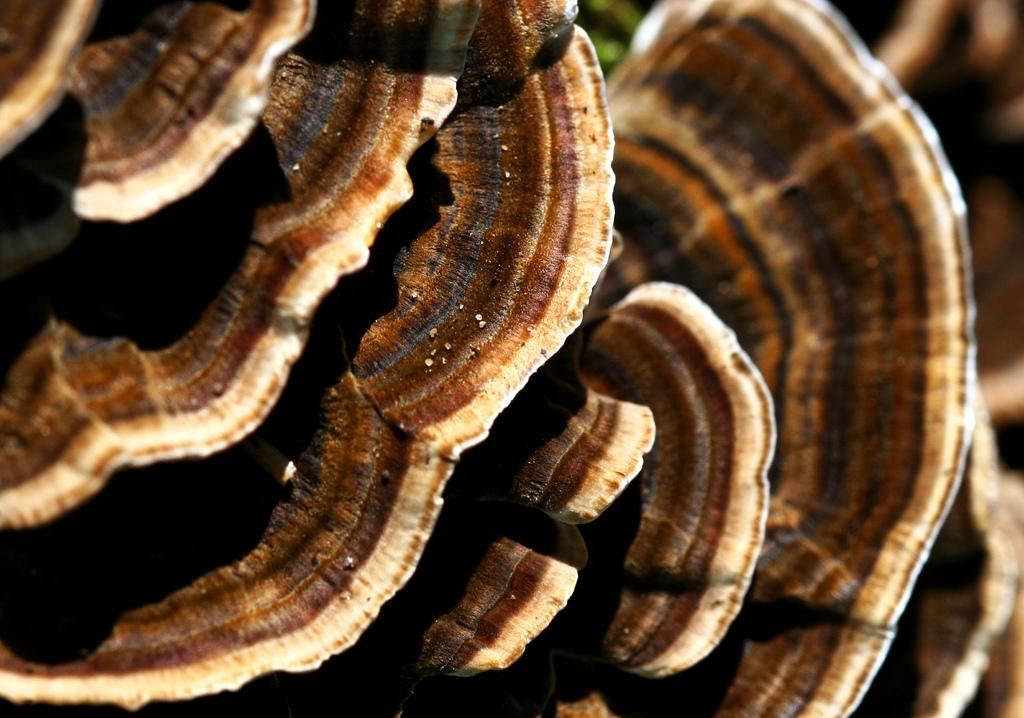What colors are present in the objects in the image? There are objects in brown, black, and cream colors in the image. Can you describe the background of the image? The background of the image is black. What shape is the sun in the image? There is no sun present in the image. What is the pail used for in the image? There is no pail present in the image. 